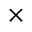<formula> <loc_0><loc_0><loc_500><loc_500>\times</formula> 